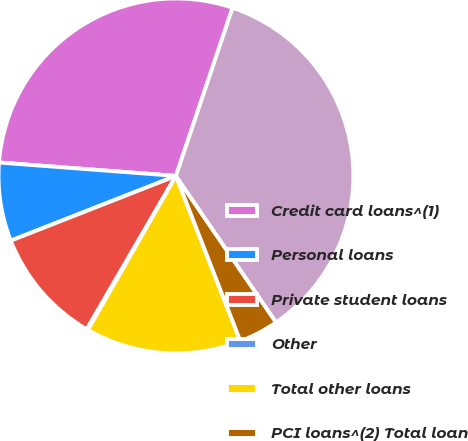Convert chart to OTSL. <chart><loc_0><loc_0><loc_500><loc_500><pie_chart><fcel>Credit card loans^(1)<fcel>Personal loans<fcel>Private student loans<fcel>Other<fcel>Total other loans<fcel>PCI loans^(2) Total loan<fcel>Net loan receivables<nl><fcel>28.97%<fcel>7.15%<fcel>10.67%<fcel>0.12%<fcel>14.18%<fcel>3.63%<fcel>35.28%<nl></chart> 